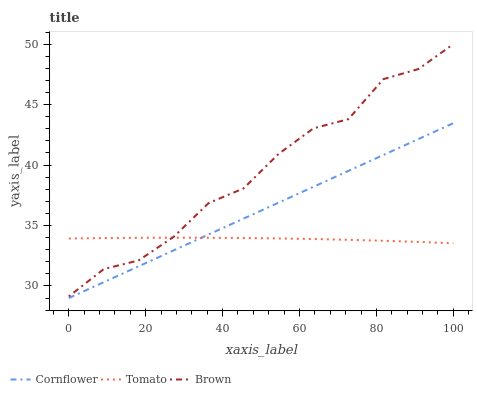Does Tomato have the minimum area under the curve?
Answer yes or no. Yes. Does Brown have the maximum area under the curve?
Answer yes or no. Yes. Does Cornflower have the minimum area under the curve?
Answer yes or no. No. Does Cornflower have the maximum area under the curve?
Answer yes or no. No. Is Cornflower the smoothest?
Answer yes or no. Yes. Is Brown the roughest?
Answer yes or no. Yes. Is Brown the smoothest?
Answer yes or no. No. Is Cornflower the roughest?
Answer yes or no. No. Does Cornflower have the lowest value?
Answer yes or no. Yes. Does Brown have the lowest value?
Answer yes or no. No. Does Brown have the highest value?
Answer yes or no. Yes. Does Cornflower have the highest value?
Answer yes or no. No. Is Cornflower less than Brown?
Answer yes or no. Yes. Is Brown greater than Cornflower?
Answer yes or no. Yes. Does Brown intersect Tomato?
Answer yes or no. Yes. Is Brown less than Tomato?
Answer yes or no. No. Is Brown greater than Tomato?
Answer yes or no. No. Does Cornflower intersect Brown?
Answer yes or no. No. 